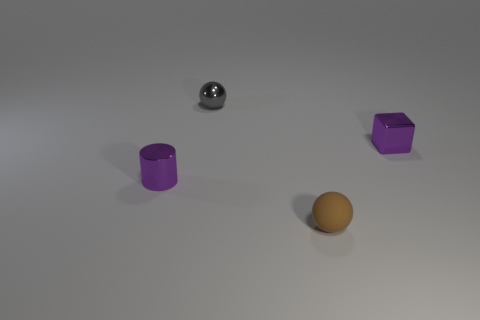Does the small shiny block have the same color as the small object on the left side of the gray metal sphere?
Provide a succinct answer. Yes. There is a small metal object that is the same color as the block; what shape is it?
Make the answer very short. Cylinder. Does the metallic block have the same color as the small cylinder?
Your response must be concise. Yes. How many things are either purple things that are to the left of the small gray thing or tiny matte spheres?
Keep it short and to the point. 2. Is the number of tiny purple metal blocks that are in front of the tiny gray ball greater than the number of tiny brown rubber blocks?
Your answer should be compact. Yes. Does the gray thing have the same shape as the object that is in front of the tiny metal cylinder?
Make the answer very short. Yes. What number of large things are metal spheres or brown rubber things?
Ensure brevity in your answer.  0. What is the color of the ball that is behind the small purple metal thing to the right of the metal cylinder?
Ensure brevity in your answer.  Gray. Do the gray thing and the tiny purple object to the right of the tiny gray shiny ball have the same material?
Offer a very short reply. Yes. What material is the object in front of the shiny cylinder?
Provide a short and direct response. Rubber. 